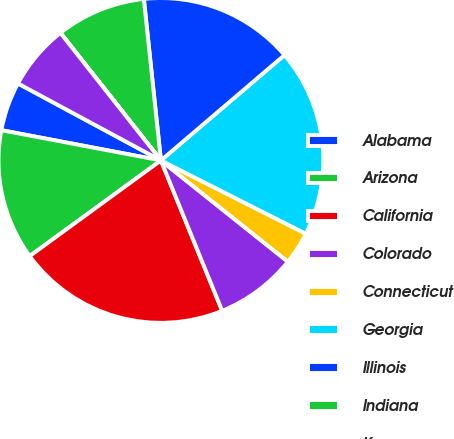<chart> <loc_0><loc_0><loc_500><loc_500><pie_chart><fcel>Alabama<fcel>Arizona<fcel>California<fcel>Colorado<fcel>Connecticut<fcel>Georgia<fcel>Illinois<fcel>Indiana<fcel>Kansas<fcel>Kentucky<nl><fcel>4.88%<fcel>13.01%<fcel>21.13%<fcel>8.13%<fcel>3.26%<fcel>18.69%<fcel>15.44%<fcel>8.94%<fcel>0.01%<fcel>6.51%<nl></chart> 